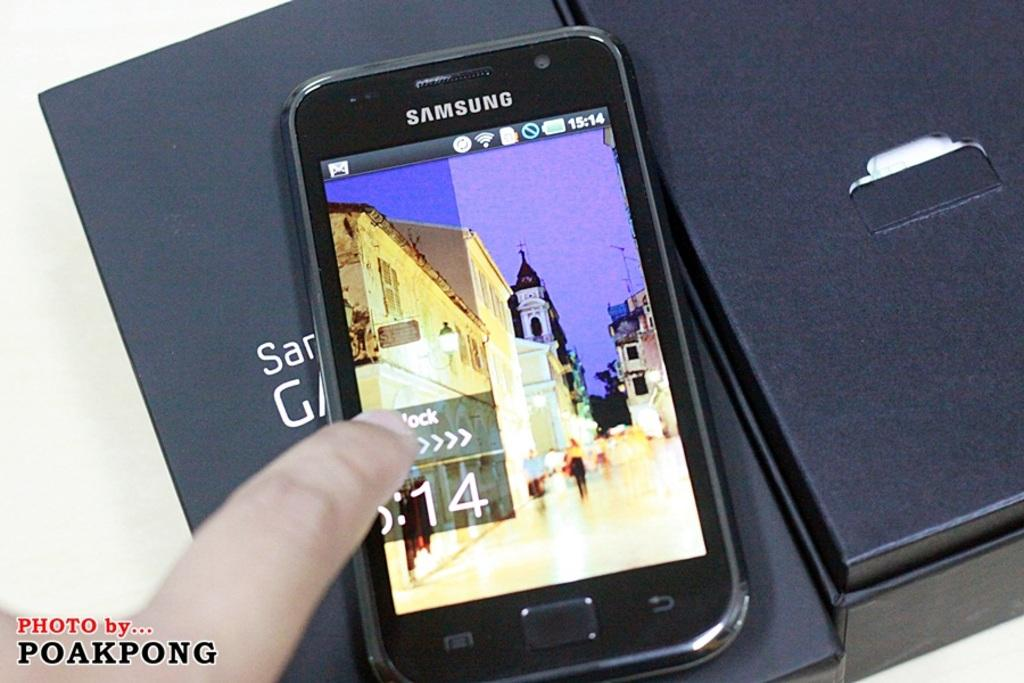<image>
Share a concise interpretation of the image provided. Samsung phones need to be swiped in order to be unlocked. 